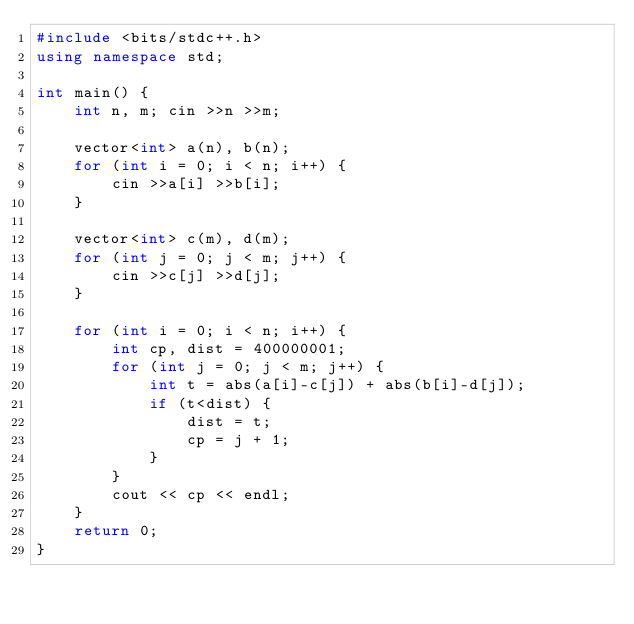<code> <loc_0><loc_0><loc_500><loc_500><_C++_>#include <bits/stdc++.h>
using namespace std;

int main() {
    int n, m; cin >>n >>m;

    vector<int> a(n), b(n);
    for (int i = 0; i < n; i++) {
        cin >>a[i] >>b[i];
    }

    vector<int> c(m), d(m);
    for (int j = 0; j < m; j++) {
        cin >>c[j] >>d[j];
    }

    for (int i = 0; i < n; i++) {
        int cp, dist = 400000001;
        for (int j = 0; j < m; j++) {
            int t = abs(a[i]-c[j]) + abs(b[i]-d[j]);
            if (t<dist) {
                dist = t;
                cp = j + 1;
            }
        }
        cout << cp << endl;
    }
    return 0;
}</code> 